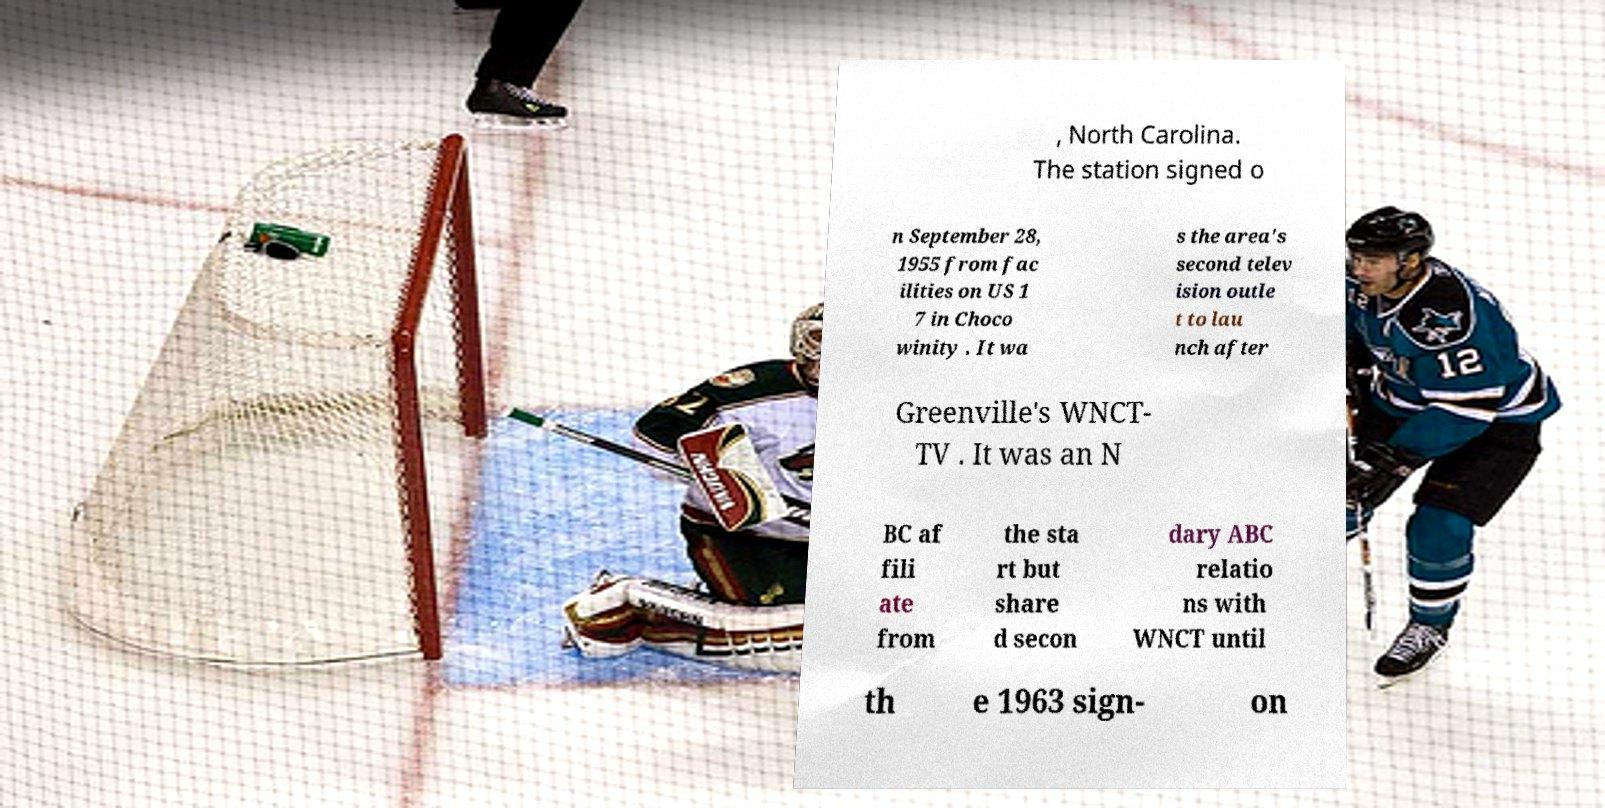What messages or text are displayed in this image? I need them in a readable, typed format. , North Carolina. The station signed o n September 28, 1955 from fac ilities on US 1 7 in Choco winity . It wa s the area's second telev ision outle t to lau nch after Greenville's WNCT- TV . It was an N BC af fili ate from the sta rt but share d secon dary ABC relatio ns with WNCT until th e 1963 sign- on 